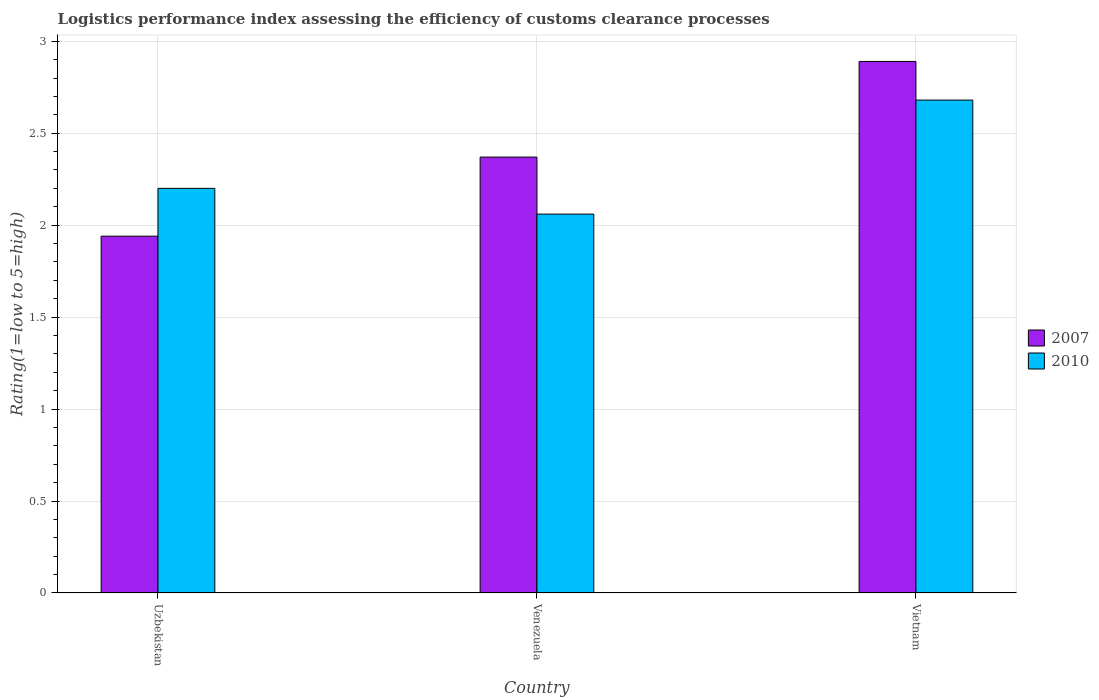How many groups of bars are there?
Offer a very short reply. 3. How many bars are there on the 2nd tick from the left?
Your response must be concise. 2. What is the label of the 1st group of bars from the left?
Your answer should be very brief. Uzbekistan. What is the Logistic performance index in 2007 in Venezuela?
Your response must be concise. 2.37. Across all countries, what is the maximum Logistic performance index in 2010?
Keep it short and to the point. 2.68. Across all countries, what is the minimum Logistic performance index in 2010?
Ensure brevity in your answer.  2.06. In which country was the Logistic performance index in 2007 maximum?
Offer a very short reply. Vietnam. In which country was the Logistic performance index in 2007 minimum?
Make the answer very short. Uzbekistan. What is the total Logistic performance index in 2007 in the graph?
Your answer should be compact. 7.2. What is the difference between the Logistic performance index in 2007 in Venezuela and that in Vietnam?
Your answer should be compact. -0.52. What is the difference between the Logistic performance index in 2010 in Venezuela and the Logistic performance index in 2007 in Uzbekistan?
Offer a terse response. 0.12. What is the average Logistic performance index in 2010 per country?
Your answer should be compact. 2.31. What is the difference between the Logistic performance index of/in 2007 and Logistic performance index of/in 2010 in Vietnam?
Keep it short and to the point. 0.21. In how many countries, is the Logistic performance index in 2007 greater than 0.7?
Provide a short and direct response. 3. What is the ratio of the Logistic performance index in 2007 in Venezuela to that in Vietnam?
Provide a succinct answer. 0.82. Is the Logistic performance index in 2010 in Uzbekistan less than that in Vietnam?
Provide a succinct answer. Yes. Is the difference between the Logistic performance index in 2007 in Uzbekistan and Vietnam greater than the difference between the Logistic performance index in 2010 in Uzbekistan and Vietnam?
Keep it short and to the point. No. What is the difference between the highest and the second highest Logistic performance index in 2010?
Provide a short and direct response. 0.48. What is the difference between the highest and the lowest Logistic performance index in 2007?
Give a very brief answer. 0.95. In how many countries, is the Logistic performance index in 2007 greater than the average Logistic performance index in 2007 taken over all countries?
Offer a very short reply. 1. What does the 1st bar from the right in Venezuela represents?
Ensure brevity in your answer.  2010. What is the difference between two consecutive major ticks on the Y-axis?
Ensure brevity in your answer.  0.5. Are the values on the major ticks of Y-axis written in scientific E-notation?
Offer a very short reply. No. How many legend labels are there?
Your response must be concise. 2. What is the title of the graph?
Ensure brevity in your answer.  Logistics performance index assessing the efficiency of customs clearance processes. What is the label or title of the Y-axis?
Keep it short and to the point. Rating(1=low to 5=high). What is the Rating(1=low to 5=high) of 2007 in Uzbekistan?
Your answer should be very brief. 1.94. What is the Rating(1=low to 5=high) in 2007 in Venezuela?
Make the answer very short. 2.37. What is the Rating(1=low to 5=high) of 2010 in Venezuela?
Give a very brief answer. 2.06. What is the Rating(1=low to 5=high) of 2007 in Vietnam?
Your answer should be very brief. 2.89. What is the Rating(1=low to 5=high) of 2010 in Vietnam?
Your answer should be compact. 2.68. Across all countries, what is the maximum Rating(1=low to 5=high) of 2007?
Offer a very short reply. 2.89. Across all countries, what is the maximum Rating(1=low to 5=high) in 2010?
Offer a very short reply. 2.68. Across all countries, what is the minimum Rating(1=low to 5=high) in 2007?
Your response must be concise. 1.94. Across all countries, what is the minimum Rating(1=low to 5=high) of 2010?
Your response must be concise. 2.06. What is the total Rating(1=low to 5=high) in 2007 in the graph?
Your response must be concise. 7.2. What is the total Rating(1=low to 5=high) in 2010 in the graph?
Your response must be concise. 6.94. What is the difference between the Rating(1=low to 5=high) in 2007 in Uzbekistan and that in Venezuela?
Keep it short and to the point. -0.43. What is the difference between the Rating(1=low to 5=high) of 2010 in Uzbekistan and that in Venezuela?
Provide a succinct answer. 0.14. What is the difference between the Rating(1=low to 5=high) of 2007 in Uzbekistan and that in Vietnam?
Offer a terse response. -0.95. What is the difference between the Rating(1=low to 5=high) in 2010 in Uzbekistan and that in Vietnam?
Provide a succinct answer. -0.48. What is the difference between the Rating(1=low to 5=high) of 2007 in Venezuela and that in Vietnam?
Ensure brevity in your answer.  -0.52. What is the difference between the Rating(1=low to 5=high) in 2010 in Venezuela and that in Vietnam?
Make the answer very short. -0.62. What is the difference between the Rating(1=low to 5=high) in 2007 in Uzbekistan and the Rating(1=low to 5=high) in 2010 in Venezuela?
Your answer should be compact. -0.12. What is the difference between the Rating(1=low to 5=high) in 2007 in Uzbekistan and the Rating(1=low to 5=high) in 2010 in Vietnam?
Offer a terse response. -0.74. What is the difference between the Rating(1=low to 5=high) of 2007 in Venezuela and the Rating(1=low to 5=high) of 2010 in Vietnam?
Give a very brief answer. -0.31. What is the average Rating(1=low to 5=high) of 2010 per country?
Give a very brief answer. 2.31. What is the difference between the Rating(1=low to 5=high) in 2007 and Rating(1=low to 5=high) in 2010 in Uzbekistan?
Offer a very short reply. -0.26. What is the difference between the Rating(1=low to 5=high) of 2007 and Rating(1=low to 5=high) of 2010 in Venezuela?
Give a very brief answer. 0.31. What is the difference between the Rating(1=low to 5=high) in 2007 and Rating(1=low to 5=high) in 2010 in Vietnam?
Provide a short and direct response. 0.21. What is the ratio of the Rating(1=low to 5=high) of 2007 in Uzbekistan to that in Venezuela?
Make the answer very short. 0.82. What is the ratio of the Rating(1=low to 5=high) of 2010 in Uzbekistan to that in Venezuela?
Your answer should be compact. 1.07. What is the ratio of the Rating(1=low to 5=high) of 2007 in Uzbekistan to that in Vietnam?
Your answer should be very brief. 0.67. What is the ratio of the Rating(1=low to 5=high) in 2010 in Uzbekistan to that in Vietnam?
Offer a very short reply. 0.82. What is the ratio of the Rating(1=low to 5=high) in 2007 in Venezuela to that in Vietnam?
Offer a terse response. 0.82. What is the ratio of the Rating(1=low to 5=high) of 2010 in Venezuela to that in Vietnam?
Your response must be concise. 0.77. What is the difference between the highest and the second highest Rating(1=low to 5=high) in 2007?
Your answer should be compact. 0.52. What is the difference between the highest and the second highest Rating(1=low to 5=high) of 2010?
Give a very brief answer. 0.48. What is the difference between the highest and the lowest Rating(1=low to 5=high) of 2007?
Your response must be concise. 0.95. What is the difference between the highest and the lowest Rating(1=low to 5=high) of 2010?
Keep it short and to the point. 0.62. 